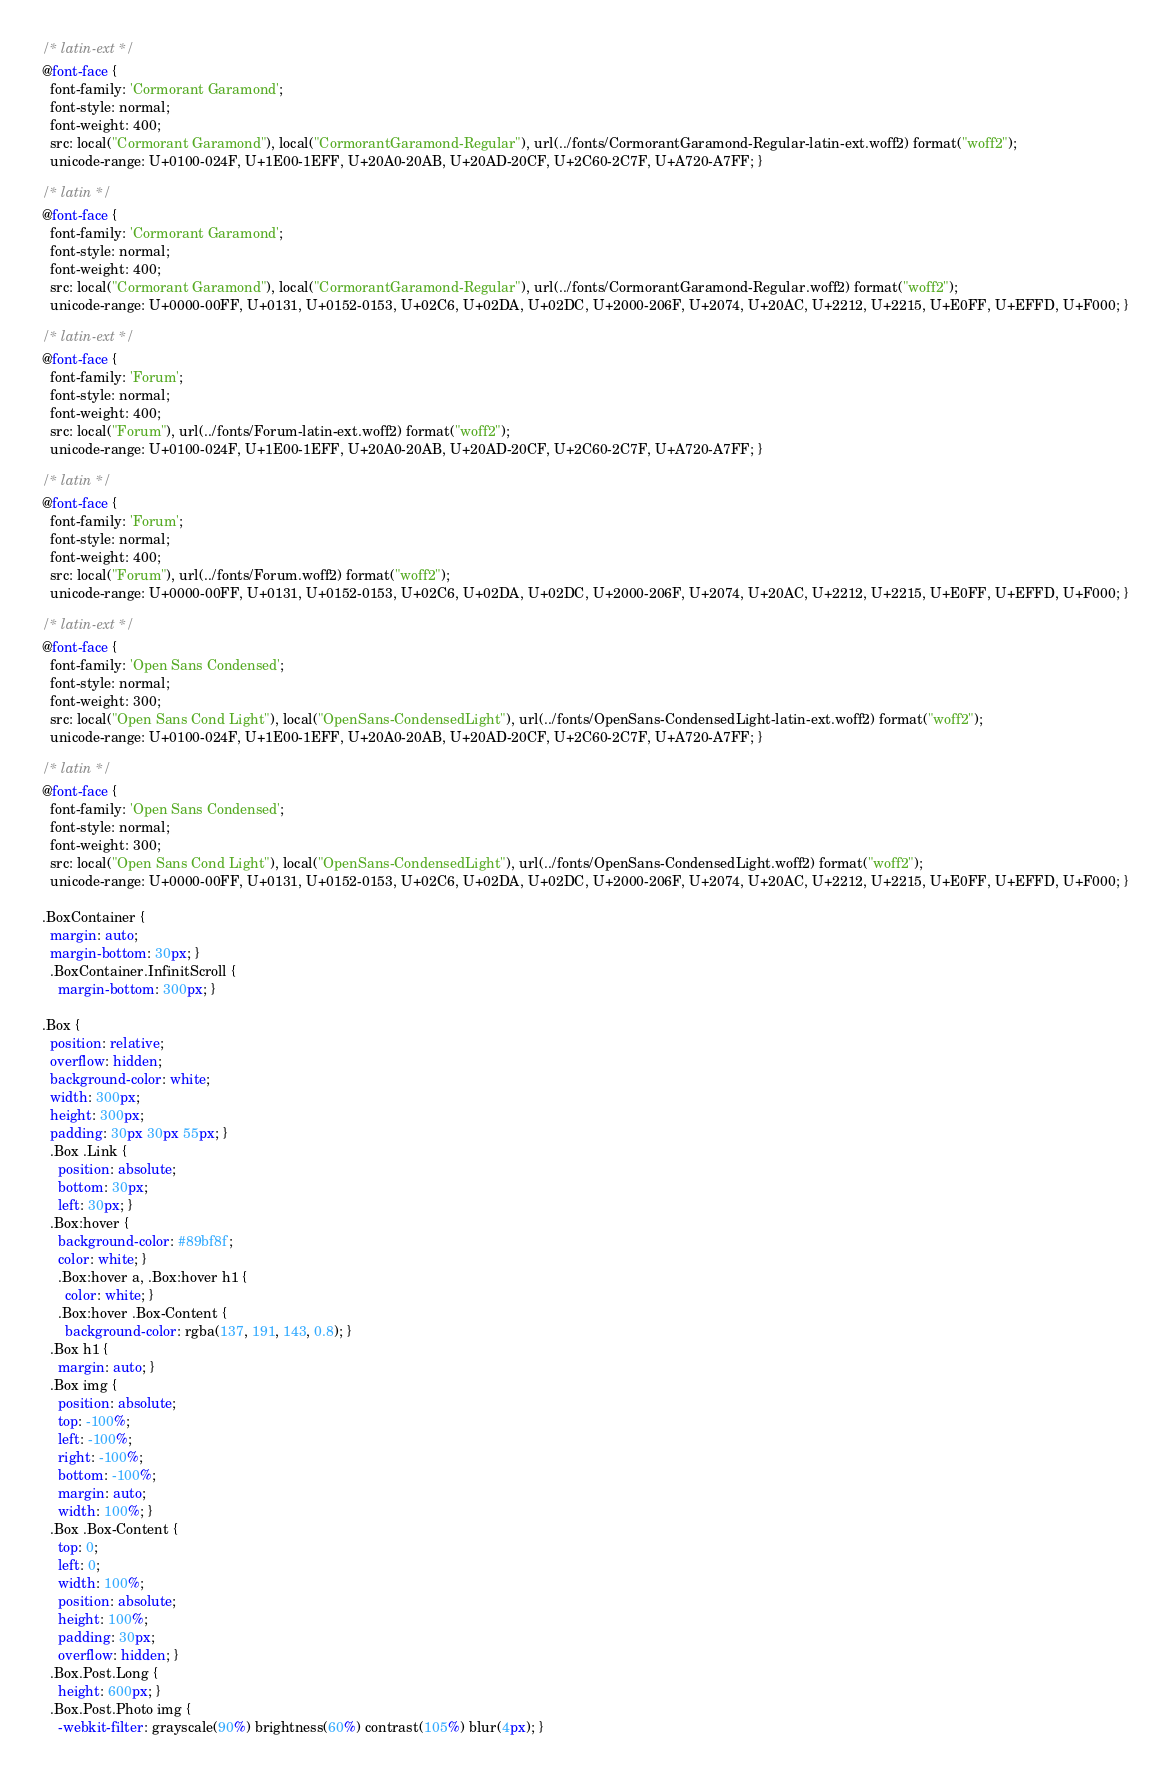Convert code to text. <code><loc_0><loc_0><loc_500><loc_500><_CSS_>/* latin-ext */
@font-face {
  font-family: 'Cormorant Garamond';
  font-style: normal;
  font-weight: 400;
  src: local("Cormorant Garamond"), local("CormorantGaramond-Regular"), url(../fonts/CormorantGaramond-Regular-latin-ext.woff2) format("woff2");
  unicode-range: U+0100-024F, U+1E00-1EFF, U+20A0-20AB, U+20AD-20CF, U+2C60-2C7F, U+A720-A7FF; }

/* latin */
@font-face {
  font-family: 'Cormorant Garamond';
  font-style: normal;
  font-weight: 400;
  src: local("Cormorant Garamond"), local("CormorantGaramond-Regular"), url(../fonts/CormorantGaramond-Regular.woff2) format("woff2");
  unicode-range: U+0000-00FF, U+0131, U+0152-0153, U+02C6, U+02DA, U+02DC, U+2000-206F, U+2074, U+20AC, U+2212, U+2215, U+E0FF, U+EFFD, U+F000; }

/* latin-ext */
@font-face {
  font-family: 'Forum';
  font-style: normal;
  font-weight: 400;
  src: local("Forum"), url(../fonts/Forum-latin-ext.woff2) format("woff2");
  unicode-range: U+0100-024F, U+1E00-1EFF, U+20A0-20AB, U+20AD-20CF, U+2C60-2C7F, U+A720-A7FF; }

/* latin */
@font-face {
  font-family: 'Forum';
  font-style: normal;
  font-weight: 400;
  src: local("Forum"), url(../fonts/Forum.woff2) format("woff2");
  unicode-range: U+0000-00FF, U+0131, U+0152-0153, U+02C6, U+02DA, U+02DC, U+2000-206F, U+2074, U+20AC, U+2212, U+2215, U+E0FF, U+EFFD, U+F000; }

/* latin-ext */
@font-face {
  font-family: 'Open Sans Condensed';
  font-style: normal;
  font-weight: 300;
  src: local("Open Sans Cond Light"), local("OpenSans-CondensedLight"), url(../fonts/OpenSans-CondensedLight-latin-ext.woff2) format("woff2");
  unicode-range: U+0100-024F, U+1E00-1EFF, U+20A0-20AB, U+20AD-20CF, U+2C60-2C7F, U+A720-A7FF; }

/* latin */
@font-face {
  font-family: 'Open Sans Condensed';
  font-style: normal;
  font-weight: 300;
  src: local("Open Sans Cond Light"), local("OpenSans-CondensedLight"), url(../fonts/OpenSans-CondensedLight.woff2) format("woff2");
  unicode-range: U+0000-00FF, U+0131, U+0152-0153, U+02C6, U+02DA, U+02DC, U+2000-206F, U+2074, U+20AC, U+2212, U+2215, U+E0FF, U+EFFD, U+F000; }

.BoxContainer {
  margin: auto;
  margin-bottom: 30px; }
  .BoxContainer.InfinitScroll {
    margin-bottom: 300px; }

.Box {
  position: relative;
  overflow: hidden;
  background-color: white;
  width: 300px;
  height: 300px;
  padding: 30px 30px 55px; }
  .Box .Link {
    position: absolute;
    bottom: 30px;
    left: 30px; }
  .Box:hover {
    background-color: #89bf8f;
    color: white; }
    .Box:hover a, .Box:hover h1 {
      color: white; }
    .Box:hover .Box-Content {
      background-color: rgba(137, 191, 143, 0.8); }
  .Box h1 {
    margin: auto; }
  .Box img {
    position: absolute;
    top: -100%;
    left: -100%;
    right: -100%;
    bottom: -100%;
    margin: auto;
    width: 100%; }
  .Box .Box-Content {
    top: 0;
    left: 0;
    width: 100%;
    position: absolute;
    height: 100%;
    padding: 30px;
    overflow: hidden; }
  .Box.Post.Long {
    height: 600px; }
  .Box.Post.Photo img {
    -webkit-filter: grayscale(90%) brightness(60%) contrast(105%) blur(4px); }</code> 